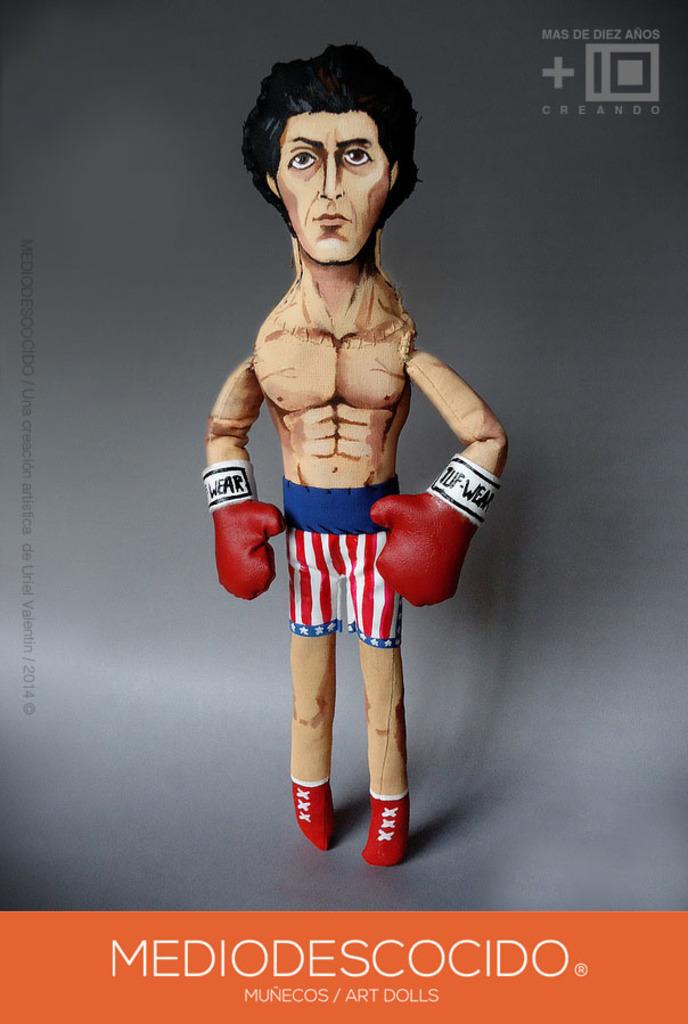What kind of art is this?
Offer a very short reply. Dolls. What is the title in large font on the orange background?
Make the answer very short. Mediodescocido. 